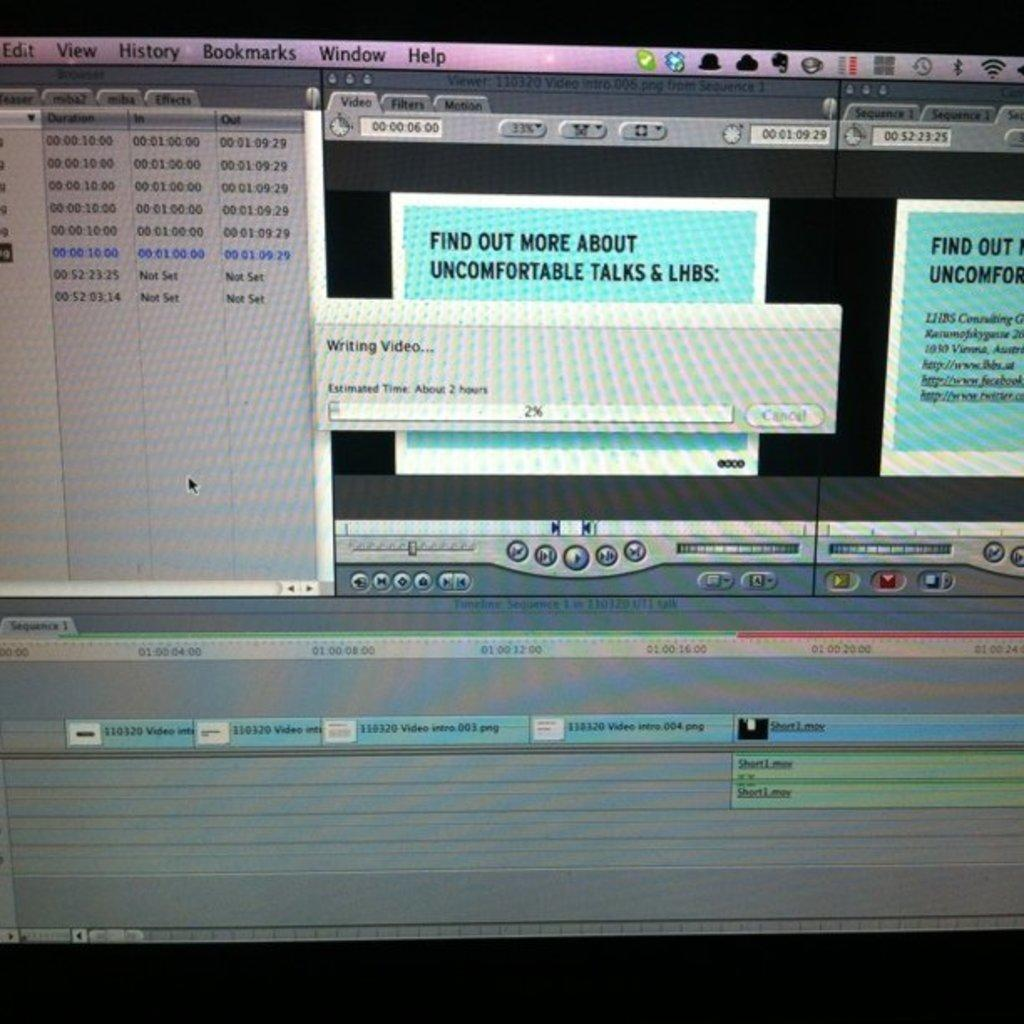Provide a one-sentence caption for the provided image. A computer screen with a message that says "find out more about uncomfortable talks & lhbs". 